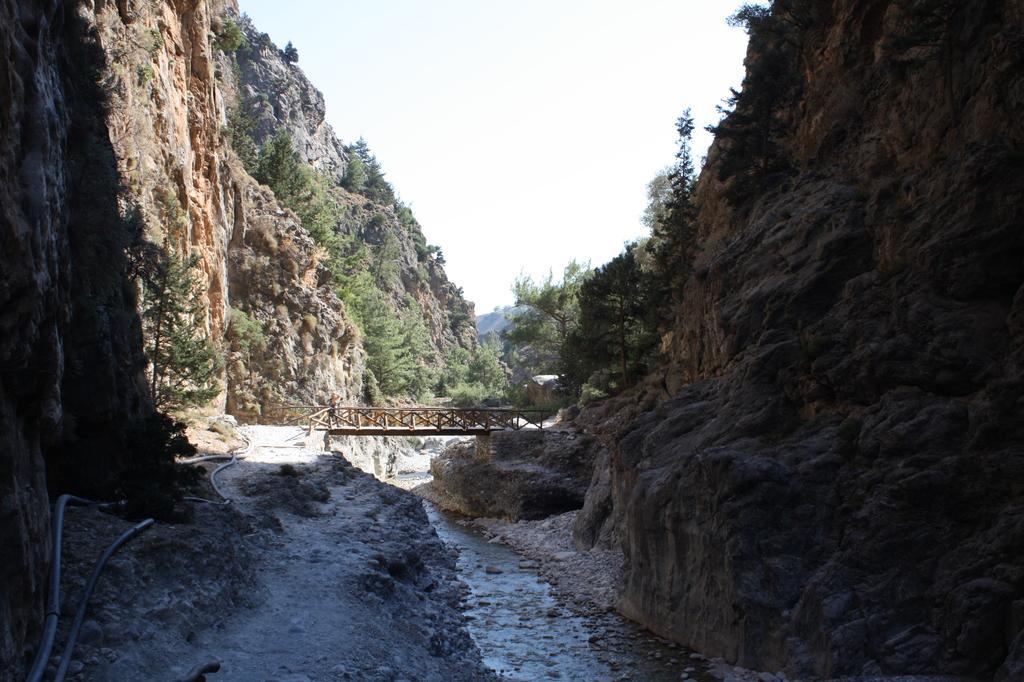In one or two sentences, can you explain what this image depicts? In this image I can see the water. On both sides of the water I can see the mountains. In the background I can see the bridge, many trees and the sky. 